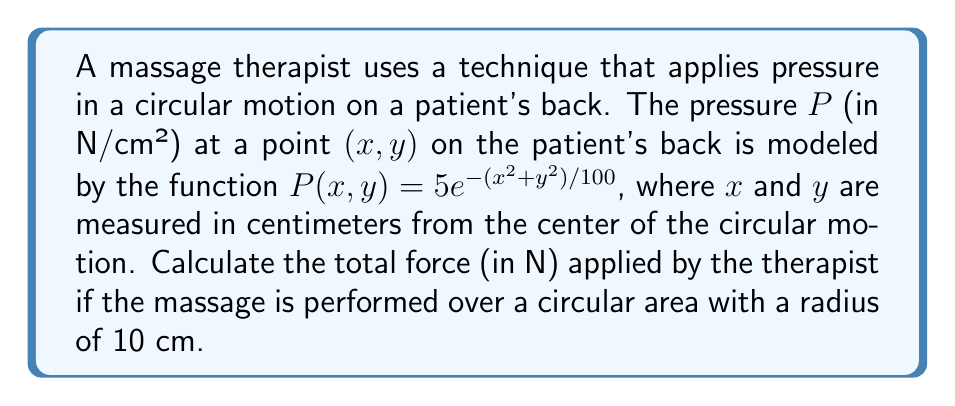Provide a solution to this math problem. To solve this problem, we need to calculate the surface integral of the pressure function over the given circular area. Here's a step-by-step approach:

1) The total force is the integral of pressure over the surface area. In this case, we need to integrate the pressure function $P(x,y)$ over a circular region with radius 10 cm.

2) The surface integral in polar coordinates is given by:

   $$F = \int_0^{2\pi} \int_0^{10} P(r,\theta) \cdot r \, dr \, d\theta$$

3) Converting the pressure function to polar coordinates:
   $x^2 + y^2 = r^2$, so $P(r,\theta) = 5e^{-r^2/100}$

4) Substituting this into our integral:

   $$F = \int_0^{2\pi} \int_0^{10} 5e^{-r^2/100} \cdot r \, dr \, d\theta$$

5) The integral is independent of $\theta$, so we can evaluate the $\theta$ integral first:

   $$F = 2\pi \int_0^{10} 5re^{-r^2/100} \, dr$$

6) To solve this integral, we can use the substitution $u = r^2/100$, $du = (2r/100)dr$, or $r\,dr = 50\,du$:

   $$F = 2\pi \cdot 5 \cdot 50 \int_0^1 e^{-u} \, du$$

7) Evaluating this integral:

   $$F = 500\pi \cdot [-e^{-u}]_0^1 = 500\pi \cdot (1 - e^{-1})$$

8) Calculating the final result:

   $$F \approx 981.75 \text{ N}$$
Answer: The total force applied by the therapist over the circular area is approximately 981.75 N. 